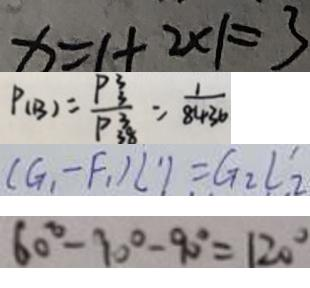Convert formula to latex. <formula><loc_0><loc_0><loc_500><loc_500>x = 1 + 2 \times 1 = 3 
 P ( B ) = \frac { P _ { 3 } ^ { 3 } } { P _ { 3 8 } ^ { 3 } } = \frac { 1 } { 8 4 3 6 } 
 ( G _ { 1 } - F _ { 1 } ) l ^ { \prime } 1 = G _ { 2 } l _ { 2 } ^ { \prime } 
 6 0 ^ { \circ } - 1 0 ^ { \circ } - 9 0 ^ { \circ } = 1 2 0 ^ { \circ }</formula> 